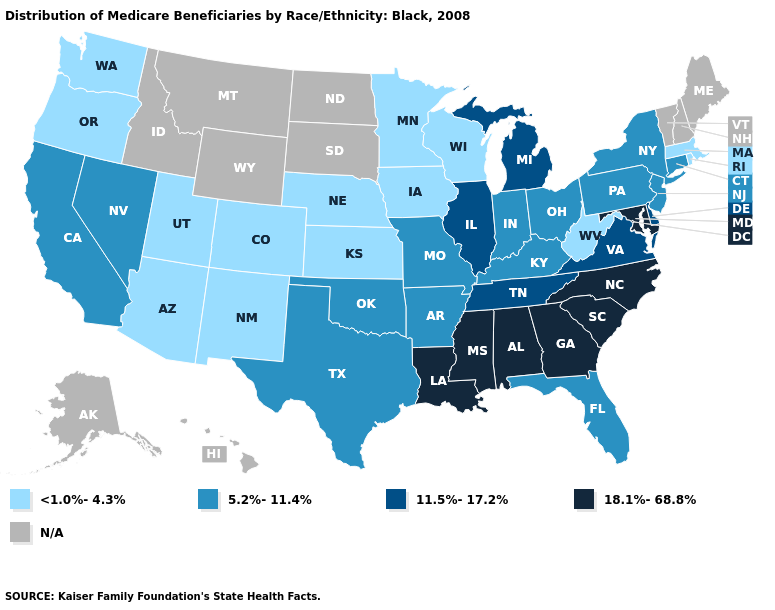What is the value of New Hampshire?
Keep it brief. N/A. Which states have the highest value in the USA?
Be succinct. Alabama, Georgia, Louisiana, Maryland, Mississippi, North Carolina, South Carolina. Does Iowa have the lowest value in the MidWest?
Short answer required. Yes. Which states have the lowest value in the Northeast?
Write a very short answer. Massachusetts, Rhode Island. Name the states that have a value in the range 11.5%-17.2%?
Give a very brief answer. Delaware, Illinois, Michigan, Tennessee, Virginia. Among the states that border Connecticut , which have the lowest value?
Short answer required. Massachusetts, Rhode Island. Name the states that have a value in the range N/A?
Be succinct. Alaska, Hawaii, Idaho, Maine, Montana, New Hampshire, North Dakota, South Dakota, Vermont, Wyoming. Name the states that have a value in the range 5.2%-11.4%?
Give a very brief answer. Arkansas, California, Connecticut, Florida, Indiana, Kentucky, Missouri, Nevada, New Jersey, New York, Ohio, Oklahoma, Pennsylvania, Texas. How many symbols are there in the legend?
Keep it brief. 5. What is the value of Georgia?
Write a very short answer. 18.1%-68.8%. Name the states that have a value in the range <1.0%-4.3%?
Give a very brief answer. Arizona, Colorado, Iowa, Kansas, Massachusetts, Minnesota, Nebraska, New Mexico, Oregon, Rhode Island, Utah, Washington, West Virginia, Wisconsin. Does Kentucky have the highest value in the South?
Answer briefly. No. What is the highest value in the USA?
Quick response, please. 18.1%-68.8%. 